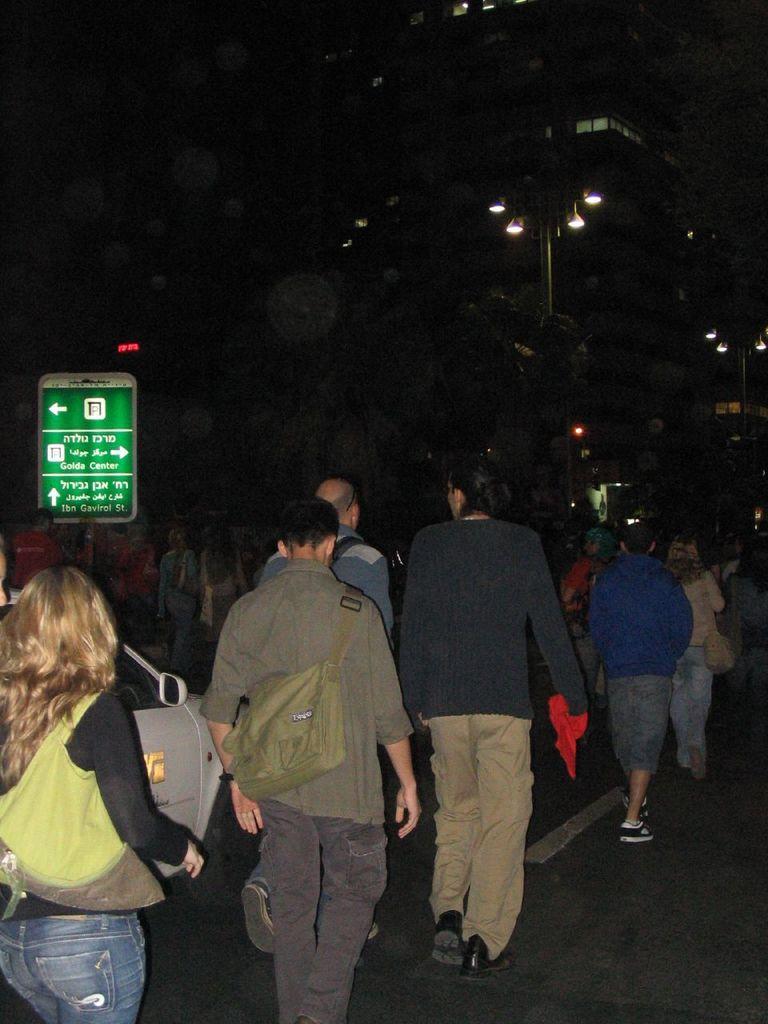Please provide a concise description of this image. In the foreground of this image, there are people wearing bags and walking on the road. We can also see a car, a board, few lights and the buildings in the dark. 